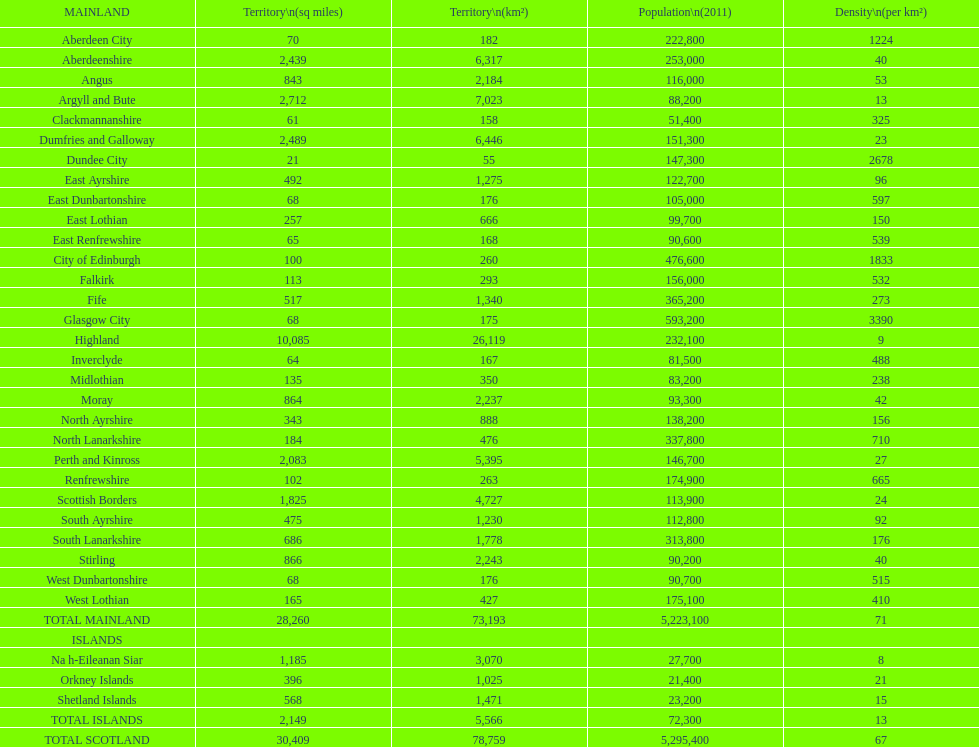What is the difference in square miles from angus and fife? 326. 